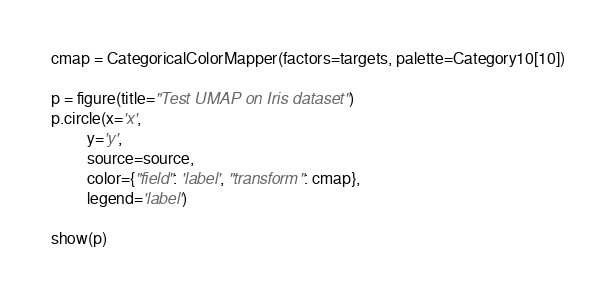<code> <loc_0><loc_0><loc_500><loc_500><_Python_>cmap = CategoricalColorMapper(factors=targets, palette=Category10[10])

p = figure(title="Test UMAP on Iris dataset")
p.circle(x='x',
         y='y',
         source=source,
         color={"field": 'label', "transform": cmap},
         legend='label')

show(p)
</code> 